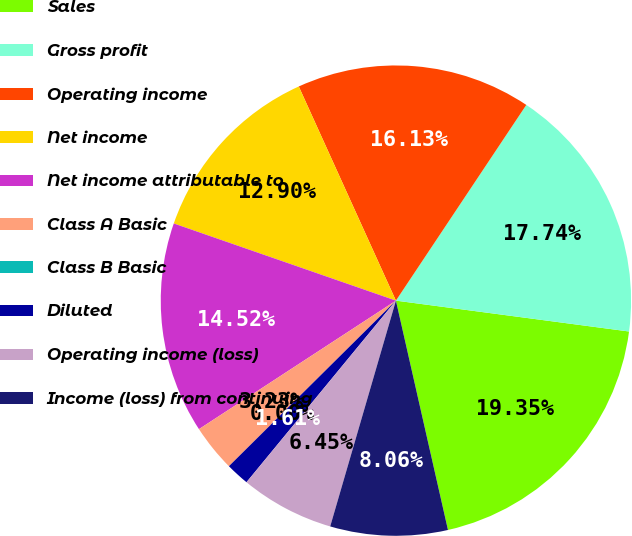Convert chart. <chart><loc_0><loc_0><loc_500><loc_500><pie_chart><fcel>Sales<fcel>Gross profit<fcel>Operating income<fcel>Net income<fcel>Net income attributable to<fcel>Class A Basic<fcel>Class B Basic<fcel>Diluted<fcel>Operating income (loss)<fcel>Income (loss) from continuing<nl><fcel>19.35%<fcel>17.74%<fcel>16.13%<fcel>12.9%<fcel>14.52%<fcel>3.23%<fcel>0.0%<fcel>1.61%<fcel>6.45%<fcel>8.06%<nl></chart> 